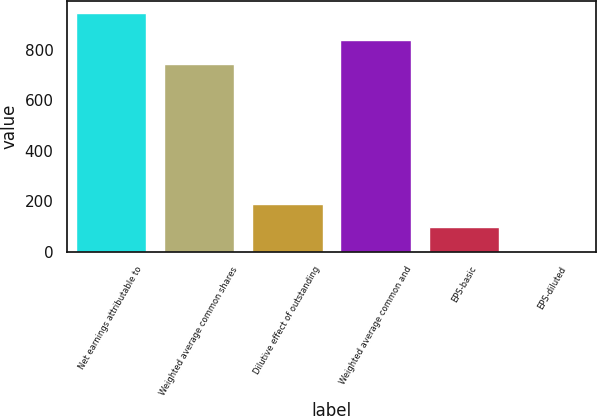<chart> <loc_0><loc_0><loc_500><loc_500><bar_chart><fcel>Net earnings attributable to<fcel>Weighted average common shares<fcel>Dilutive effect of outstanding<fcel>Weighted average common and<fcel>EPS-basic<fcel>EPS-diluted<nl><fcel>945.6<fcel>744.4<fcel>190.12<fcel>838.84<fcel>95.68<fcel>1.24<nl></chart> 